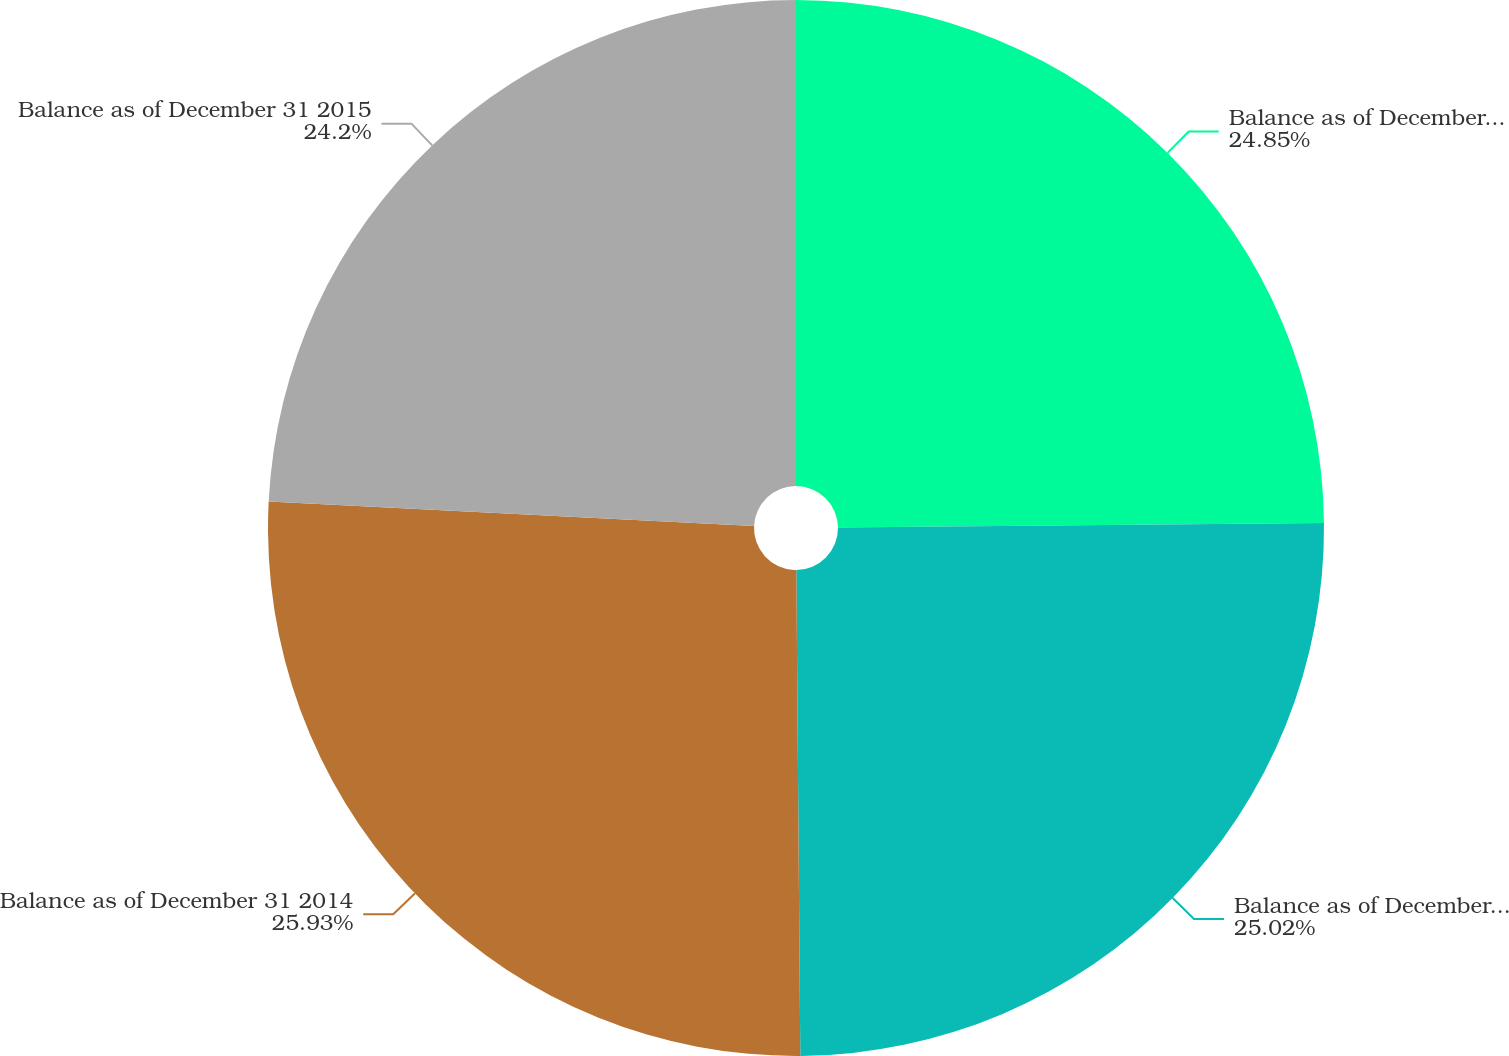Convert chart to OTSL. <chart><loc_0><loc_0><loc_500><loc_500><pie_chart><fcel>Balance as of December 31 2012<fcel>Balance as of December 31 2013<fcel>Balance as of December 31 2014<fcel>Balance as of December 31 2015<nl><fcel>24.85%<fcel>25.02%<fcel>25.93%<fcel>24.2%<nl></chart> 